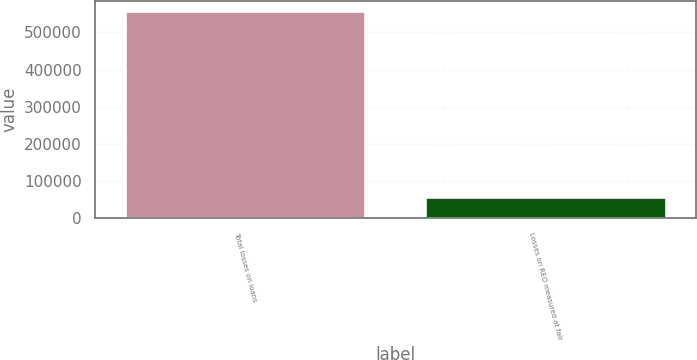<chart> <loc_0><loc_0><loc_500><loc_500><bar_chart><fcel>Total losses on loans<fcel>Losses on REO measured at fair<nl><fcel>556685<fcel>56460<nl></chart> 